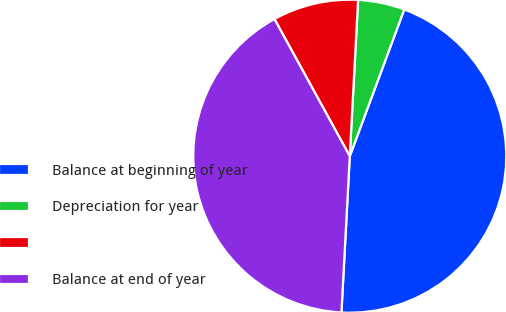Convert chart. <chart><loc_0><loc_0><loc_500><loc_500><pie_chart><fcel>Balance at beginning of year<fcel>Depreciation for year<fcel>Unnamed: 2<fcel>Balance at end of year<nl><fcel>45.19%<fcel>4.81%<fcel>8.84%<fcel>41.16%<nl></chart> 